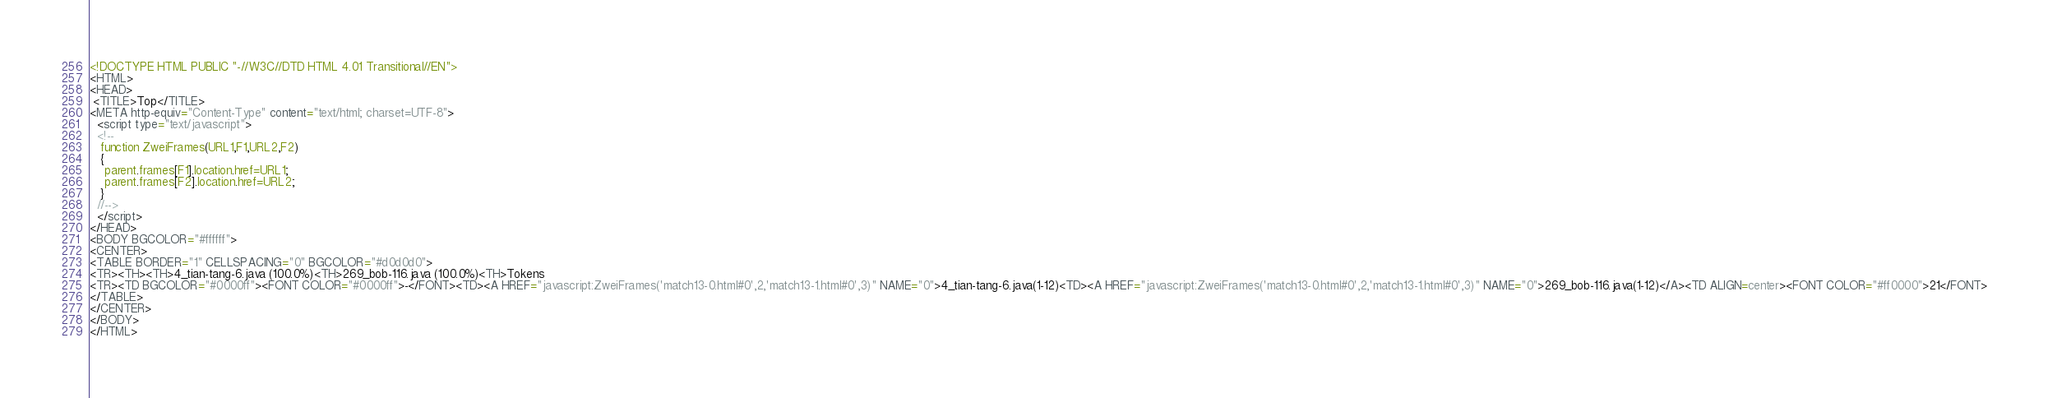Convert code to text. <code><loc_0><loc_0><loc_500><loc_500><_HTML_><!DOCTYPE HTML PUBLIC "-//W3C//DTD HTML 4.01 Transitional//EN">
<HTML>
<HEAD>
 <TITLE>Top</TITLE>
<META http-equiv="Content-Type" content="text/html; charset=UTF-8">
  <script type="text/javascript">
  <!--
   function ZweiFrames(URL1,F1,URL2,F2)
   {
    parent.frames[F1].location.href=URL1;
    parent.frames[F2].location.href=URL2;
   }
  //-->
  </script>
</HEAD>
<BODY BGCOLOR="#ffffff">
<CENTER>
<TABLE BORDER="1" CELLSPACING="0" BGCOLOR="#d0d0d0">
<TR><TH><TH>4_tian-tang-6.java (100.0%)<TH>269_bob-116.java (100.0%)<TH>Tokens
<TR><TD BGCOLOR="#0000ff"><FONT COLOR="#0000ff">-</FONT><TD><A HREF="javascript:ZweiFrames('match13-0.html#0',2,'match13-1.html#0',3)" NAME="0">4_tian-tang-6.java(1-12)<TD><A HREF="javascript:ZweiFrames('match13-0.html#0',2,'match13-1.html#0',3)" NAME="0">269_bob-116.java(1-12)</A><TD ALIGN=center><FONT COLOR="#ff0000">21</FONT>
</TABLE>
</CENTER>
</BODY>
</HTML>

</code> 